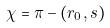<formula> <loc_0><loc_0><loc_500><loc_500>\chi = \pi - ( r _ { 0 } , s )</formula> 